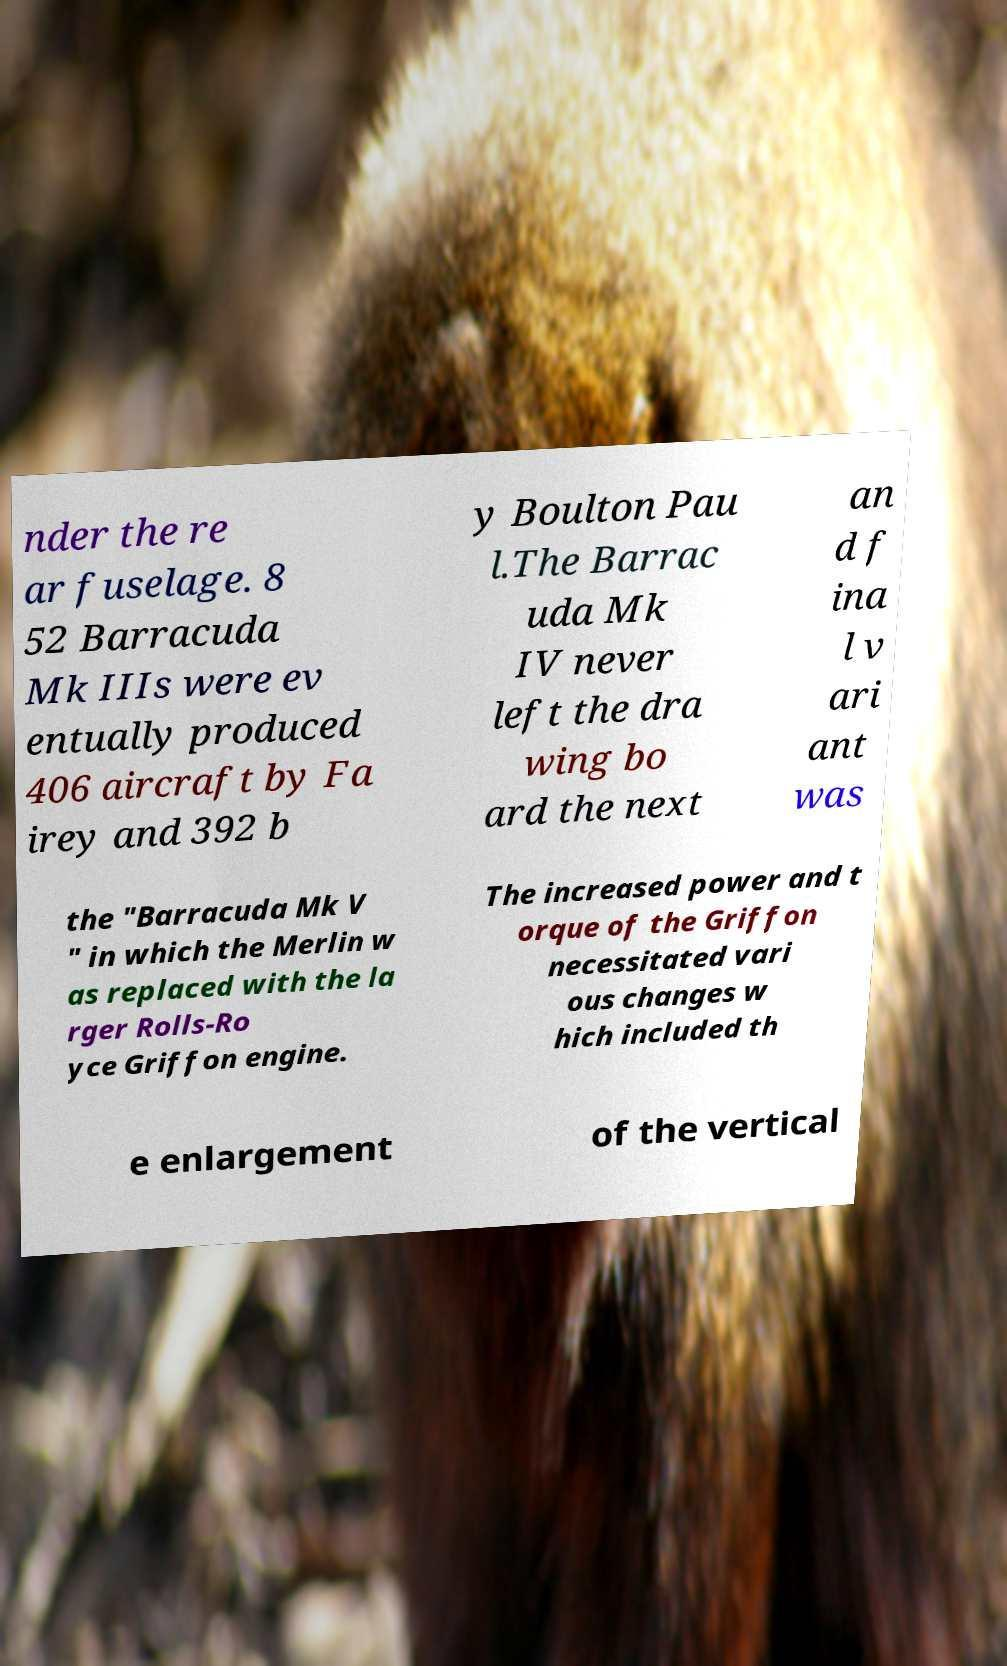Could you assist in decoding the text presented in this image and type it out clearly? nder the re ar fuselage. 8 52 Barracuda Mk IIIs were ev entually produced 406 aircraft by Fa irey and 392 b y Boulton Pau l.The Barrac uda Mk IV never left the dra wing bo ard the next an d f ina l v ari ant was the "Barracuda Mk V " in which the Merlin w as replaced with the la rger Rolls-Ro yce Griffon engine. The increased power and t orque of the Griffon necessitated vari ous changes w hich included th e enlargement of the vertical 